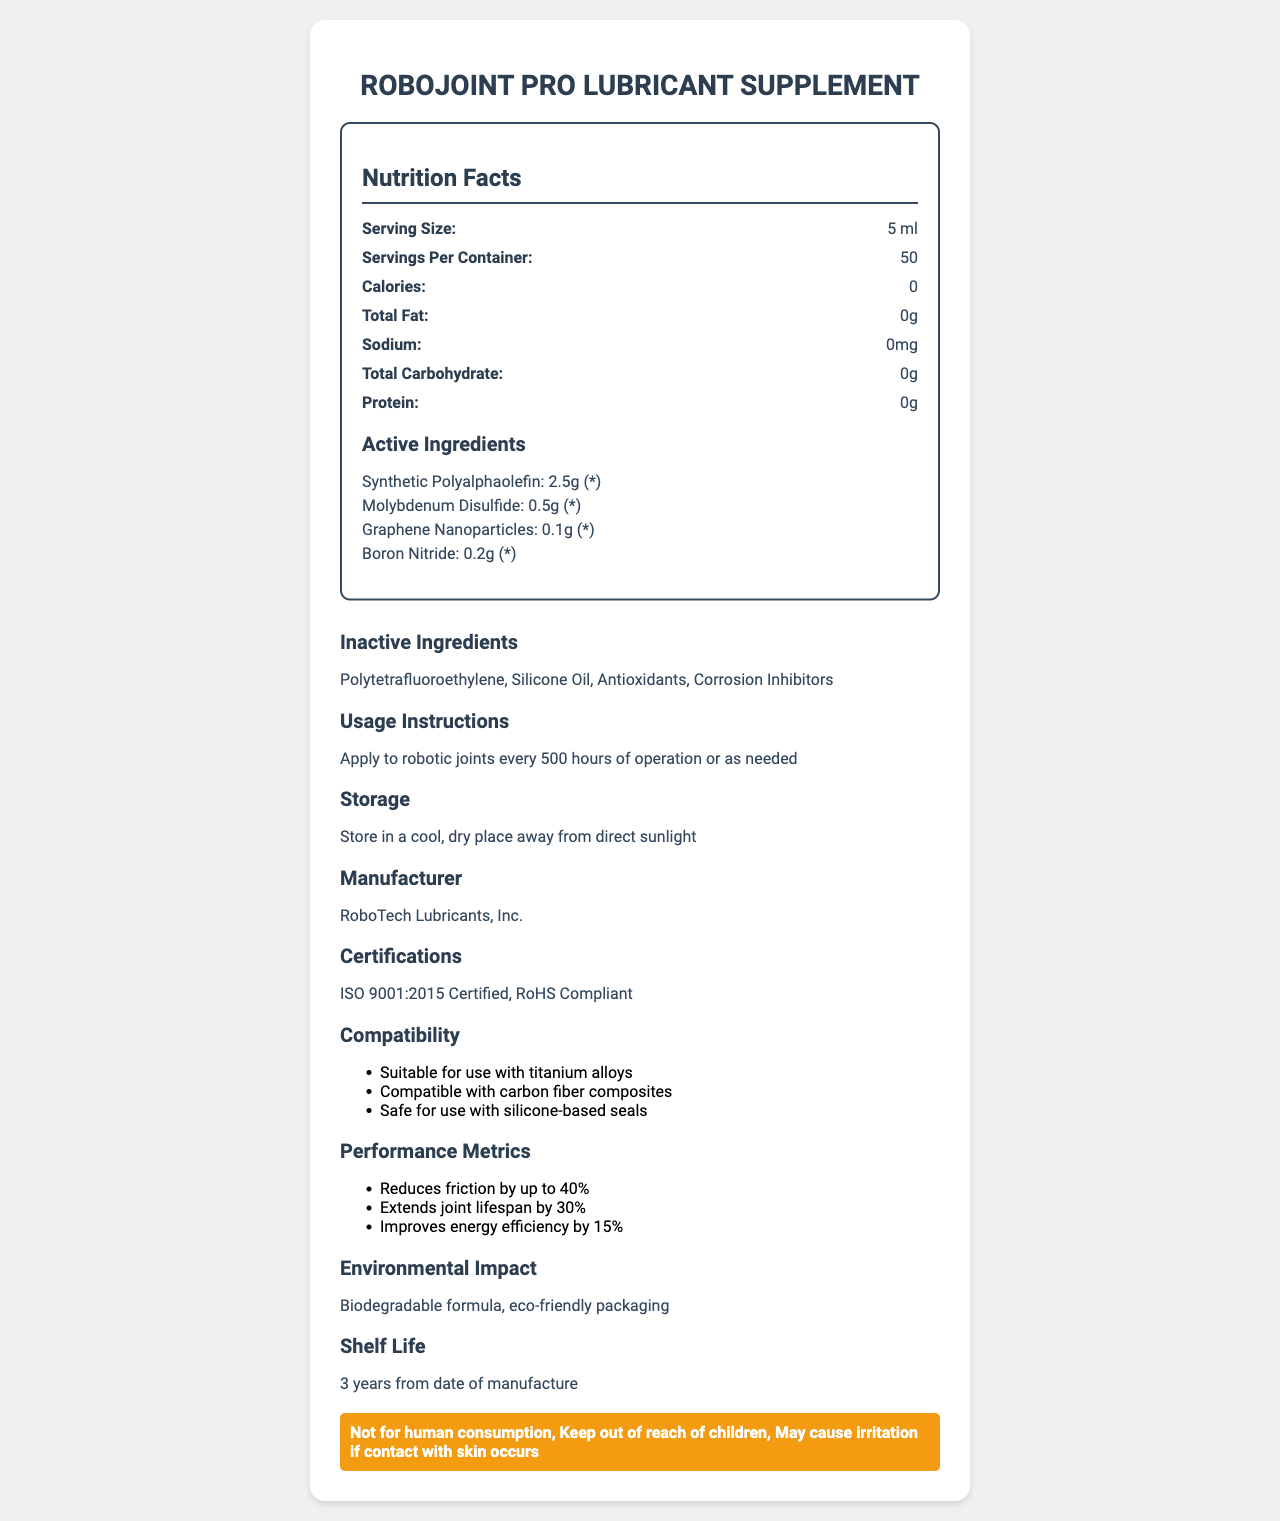what is the serving size? The serving size listed in the nutrition facts is 5 ml.
Answer: 5 ml how many servings are there per container? The nutrition facts state that there are 50 servings per container.
Answer: 50 how many calories are there per serving? The nutrition facts indicate that there are 0 calories per serving.
Answer: 0 what are the total carbohydrates in the product? According to the nutrition facts, the total carbohydrates in the product are 0g per serving.
Answer: 0g who is the manufacturer of this product? The manufacturer listed on the document is RoboTech Lubricants, Inc.
Answer: RoboTech Lubricants, Inc. which of the following is an active ingredient in the supplement? A. Silicone Oil B. Graphene Nanoparticles C. Antioxidants Graphene Nanoparticles is listed as an active ingredient, while Silicone Oil and Antioxidants are inactive ingredients.
Answer: B what type of certification does this product have? A. ISO 9001:2015 B. FDA Approved C. CE Certified The document lists the certification as "ISO 9001:2015 Certified."
Answer: A true or false: the product improves energy efficiency by 15% The listed performance metrics mention that the product improves energy efficiency by 15%.
Answer: True is this product suitable for use with silicone-based seals? The compatibility section states that the product is safe for use with silicone-based seals.
Answer: Yes what is the main purpose of this document? The document focuses on giving an extensive overview of the RoboJoint Pro Lubricant Supplement, including various metrics and certifications.
Answer: To provide detailed information about the RoboJoint Pro Lubricant Supplement, including its nutrition facts, active and inactive ingredients, usage instructions, and other relevant product details. what is the shelf life of the supplement? The additional information section indicates that the shelf life is 3 years from the date of manufacture.
Answer: 3 years from date of manufacture how often should the supplement be applied to robotic joints? The usage instructions specify applying the supplement every 500 hours of operation or as needed.
Answer: Every 500 hours of operation or as needed what are the potential hazards of using this product? The document lists multiple warnings: not for human consumption, keeping out of reach of children, and irritation risk if it comes in contact with skin.
Answer: Not for human consumption, Keep out of reach of children, May cause irritation if contact with skin occurs is this product biodegradable? The environmental impact section notes that the product has a biodegradable formula.
Answer: Yes what can you infer about the inactive ingredients? Inactive ingredients like Polytetrafluoroethylene, Silicone Oil, Antioxidants, and Corrosion Inhibitors are often used to support the effectiveness and longevity of the active components.
Answer: Used to enhance the performance and stability of the active ingredients what is the specific daily value percentage of Synthetic Polyalphaolefin in the supplement? The document lists the daily value as "*", but it does not specify what percentage this represents.
Answer: Cannot be determined 